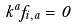<formula> <loc_0><loc_0><loc_500><loc_500>k ^ { a } f _ { i , a } = 0</formula> 